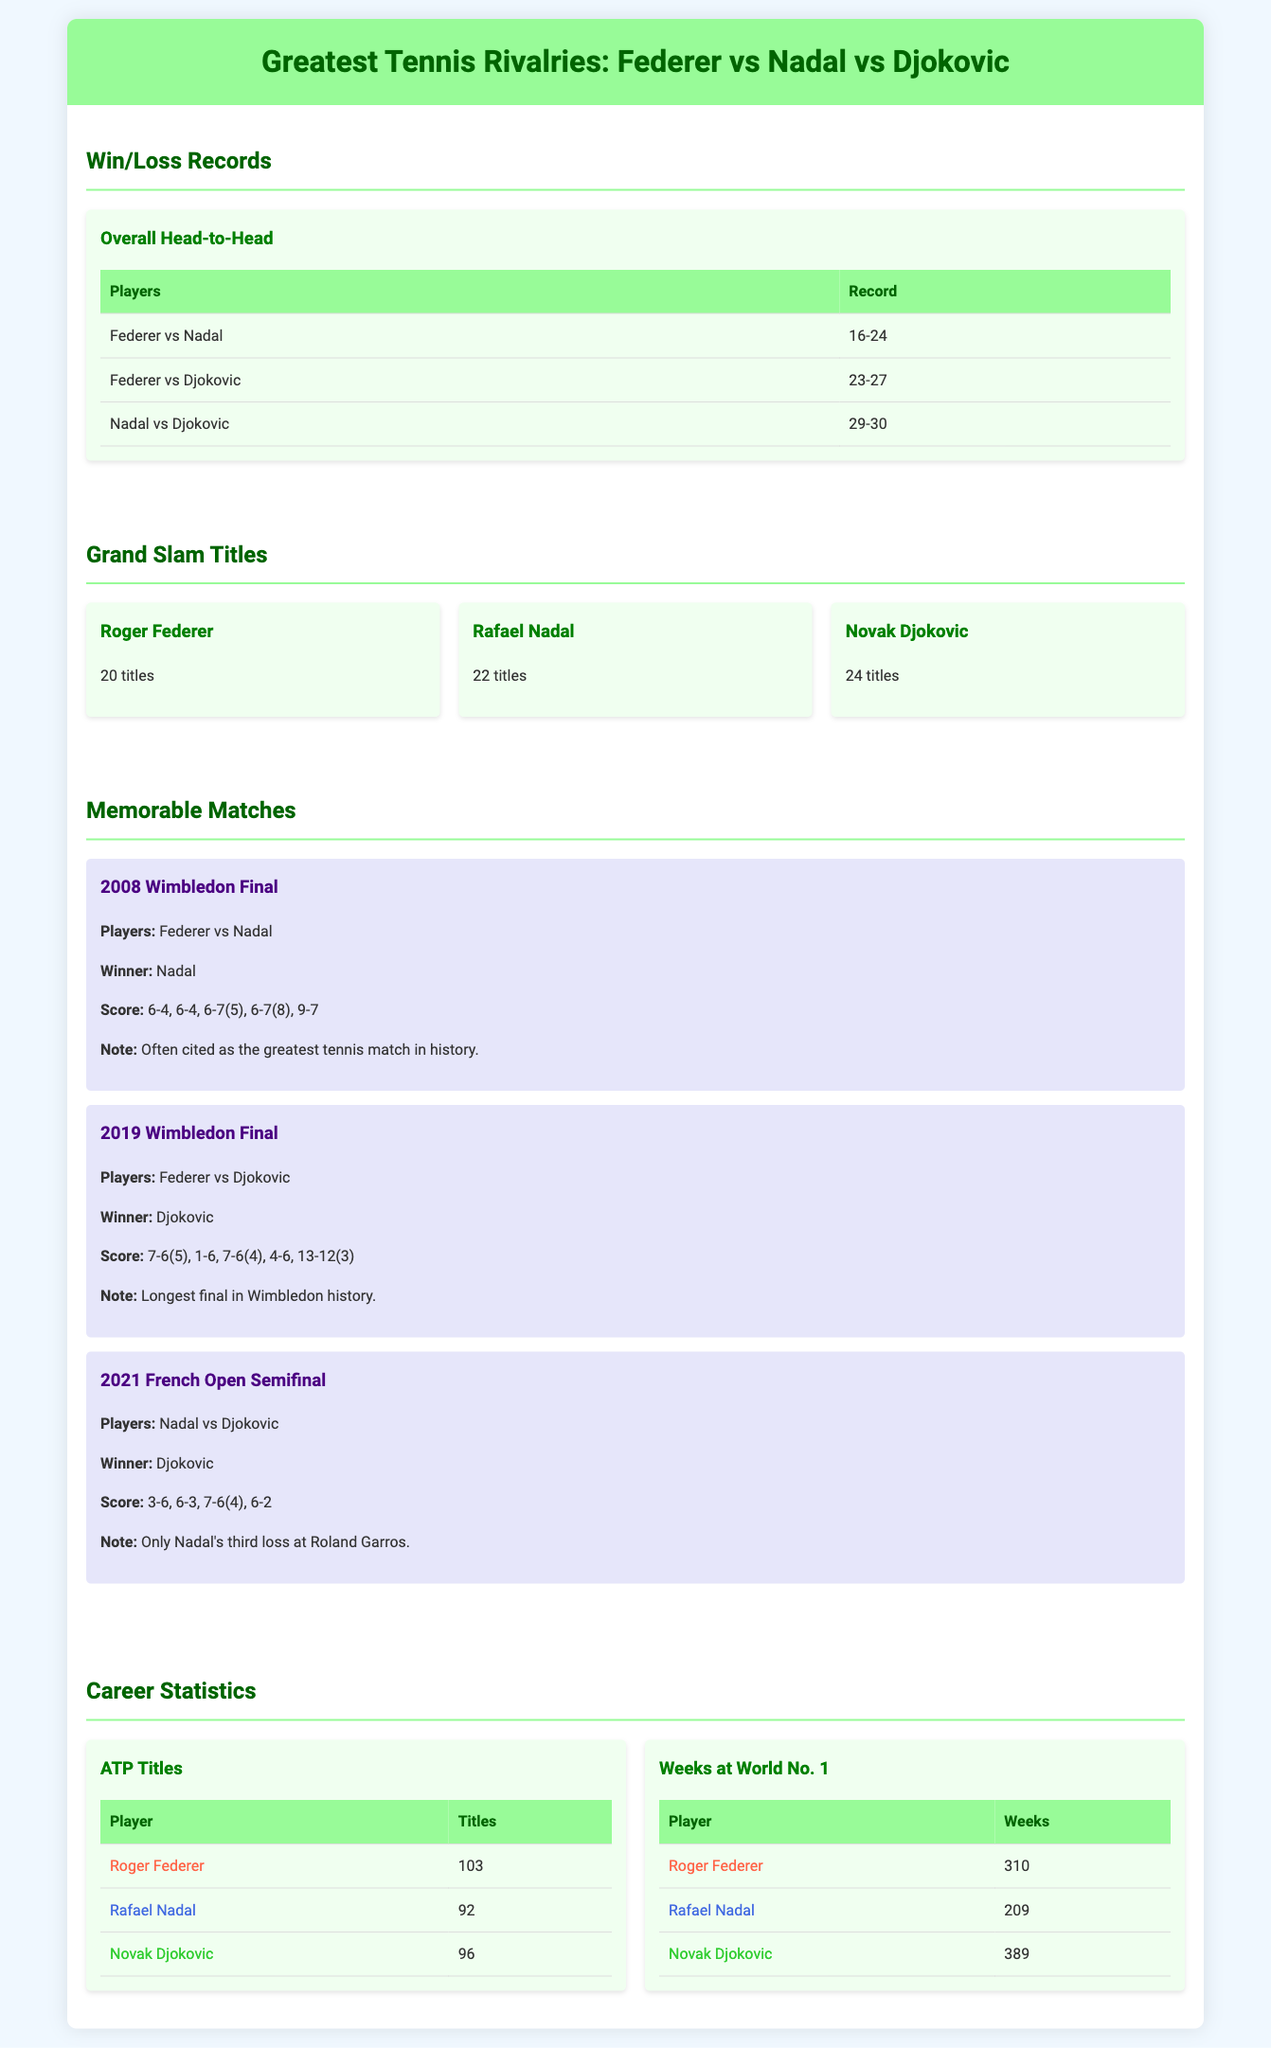What is the head-to-head record between Federer and Nadal? The head-to-head record between Federer and Nadal is listed in the document, which shows that Federer has won 16 matches while Nadal has won 24 matches.
Answer: 16-24 How many Grand Slam titles does Novak Djokovic have? The Grand Slam titles section provides the number of titles each player has, indicating that Djokovic has 24 titles.
Answer: 24 titles Which player has the most weeks at World No. 1? The document contains a table under the 'Weeks at World No. 1' section, showing that Djokovic has spent the most weeks at this ranking with 389.
Answer: 389 What is the score of the 2008 Wimbledon Final? In the memorable matches section, it lists the score for the 2008 Wimbledon Final where Nadal won against Federer, which is 6-4, 6-4, 6-7, 6-7, 9-7.
Answer: 6-4, 6-4, 6-7(5), 6-7(8), 9-7 How many ATP titles has Rafael Nadal won? The ATP titles section shows that Rafael Nadal has won a total of 92 ATP titles in his career.
Answer: 92 Which match is noted as often cited as the greatest tennis match in history? The document specifies that the 2008 Wimbledon Final between Federer and Nadal is often cited as the greatest tennis match in history.
Answer: 2008 Wimbledon Final Who has the most Grand Slam titles among the three players? In the Grand Slam Titles section, it is indicated that Djokovic has the highest number of titles, which is 24.
Answer: 24 titles What is the total number of Grand Slam titles collectively held by Federer, Nadal, and Djokovic? The total number of Grand Slam titles can be calculated by adding 20, 22, and 24, yielding a total of 66 titles among the three players.
Answer: 66 titles 